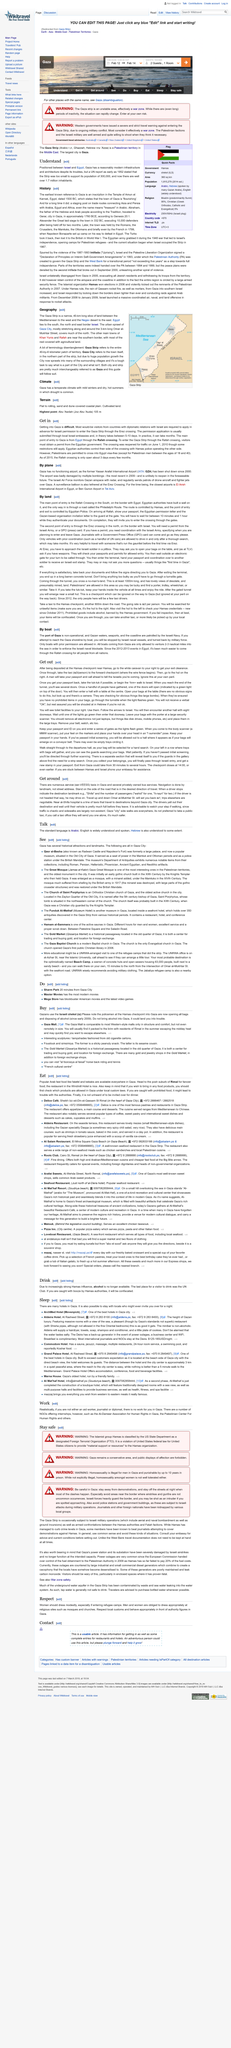Point out several critical features in this image. The Gaza Strip is home to several main towns and cities, including Gaza City, which is located in the northernmost part of the strip. The other main towns in the Gaza Strip include Khan Yunis and Rafah. Gaza has a temperate climate with mild winters and dry, hot summers. During the summer, drought is common due to the hot and arid conditions. The Gaza Strip is a 40-kilometer long piece of land. 